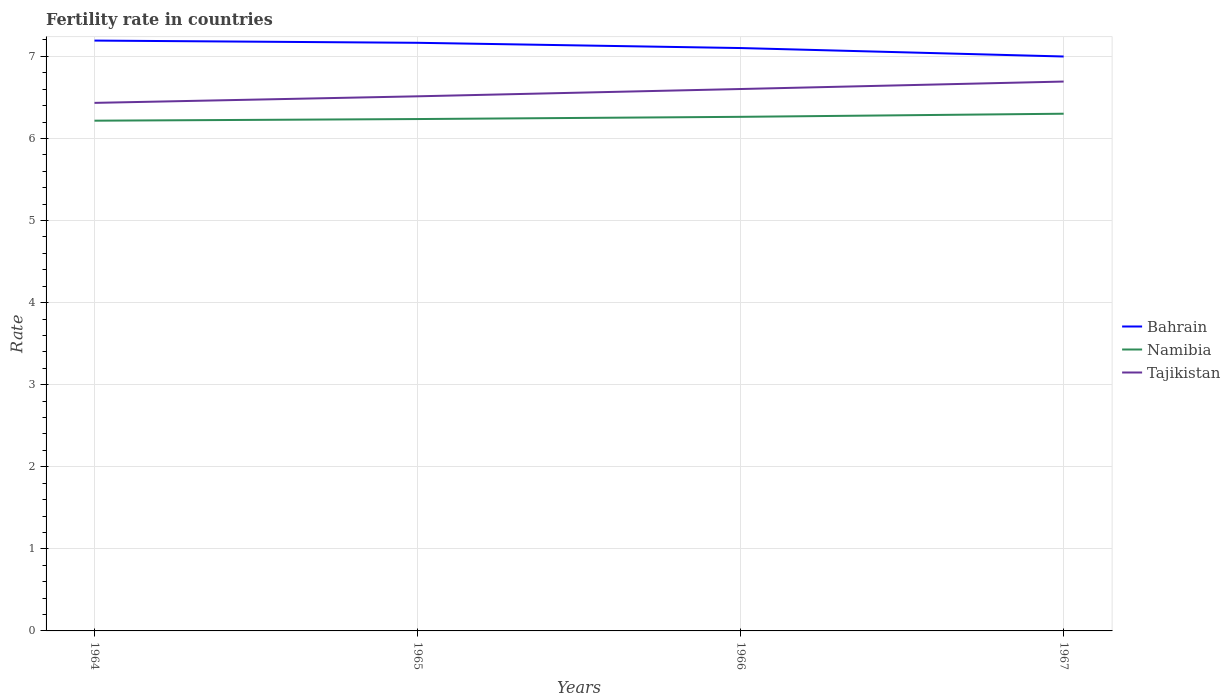Across all years, what is the maximum fertility rate in Bahrain?
Offer a terse response. 7. In which year was the fertility rate in Namibia maximum?
Offer a very short reply. 1964. What is the total fertility rate in Bahrain in the graph?
Make the answer very short. 0.09. What is the difference between the highest and the second highest fertility rate in Bahrain?
Your answer should be compact. 0.19. What is the difference between the highest and the lowest fertility rate in Namibia?
Offer a terse response. 2. How many lines are there?
Provide a short and direct response. 3. Are the values on the major ticks of Y-axis written in scientific E-notation?
Your response must be concise. No. Does the graph contain any zero values?
Make the answer very short. No. How are the legend labels stacked?
Offer a very short reply. Vertical. What is the title of the graph?
Keep it short and to the point. Fertility rate in countries. What is the label or title of the Y-axis?
Offer a terse response. Rate. What is the Rate of Bahrain in 1964?
Offer a terse response. 7.19. What is the Rate of Namibia in 1964?
Ensure brevity in your answer.  6.22. What is the Rate in Tajikistan in 1964?
Provide a succinct answer. 6.43. What is the Rate of Bahrain in 1965?
Your answer should be very brief. 7.17. What is the Rate in Namibia in 1965?
Give a very brief answer. 6.24. What is the Rate of Tajikistan in 1965?
Keep it short and to the point. 6.51. What is the Rate in Bahrain in 1966?
Provide a short and direct response. 7.1. What is the Rate of Namibia in 1966?
Give a very brief answer. 6.26. What is the Rate of Tajikistan in 1966?
Ensure brevity in your answer.  6.6. What is the Rate in Bahrain in 1967?
Provide a short and direct response. 7. What is the Rate in Namibia in 1967?
Ensure brevity in your answer.  6.3. What is the Rate in Tajikistan in 1967?
Ensure brevity in your answer.  6.69. Across all years, what is the maximum Rate in Bahrain?
Make the answer very short. 7.19. Across all years, what is the maximum Rate in Namibia?
Ensure brevity in your answer.  6.3. Across all years, what is the maximum Rate in Tajikistan?
Your answer should be compact. 6.69. Across all years, what is the minimum Rate in Bahrain?
Make the answer very short. 7. Across all years, what is the minimum Rate in Namibia?
Your answer should be very brief. 6.22. Across all years, what is the minimum Rate of Tajikistan?
Ensure brevity in your answer.  6.43. What is the total Rate of Bahrain in the graph?
Keep it short and to the point. 28.46. What is the total Rate of Namibia in the graph?
Keep it short and to the point. 25.02. What is the total Rate in Tajikistan in the graph?
Provide a short and direct response. 26.24. What is the difference between the Rate of Bahrain in 1964 and that in 1965?
Give a very brief answer. 0.03. What is the difference between the Rate in Namibia in 1964 and that in 1965?
Offer a very short reply. -0.02. What is the difference between the Rate in Tajikistan in 1964 and that in 1965?
Make the answer very short. -0.08. What is the difference between the Rate of Bahrain in 1964 and that in 1966?
Provide a succinct answer. 0.09. What is the difference between the Rate in Namibia in 1964 and that in 1966?
Make the answer very short. -0.05. What is the difference between the Rate of Tajikistan in 1964 and that in 1966?
Provide a succinct answer. -0.17. What is the difference between the Rate in Bahrain in 1964 and that in 1967?
Offer a terse response. 0.19. What is the difference between the Rate in Namibia in 1964 and that in 1967?
Your answer should be compact. -0.09. What is the difference between the Rate of Tajikistan in 1964 and that in 1967?
Your response must be concise. -0.26. What is the difference between the Rate in Bahrain in 1965 and that in 1966?
Offer a very short reply. 0.06. What is the difference between the Rate of Namibia in 1965 and that in 1966?
Provide a short and direct response. -0.03. What is the difference between the Rate in Tajikistan in 1965 and that in 1966?
Ensure brevity in your answer.  -0.09. What is the difference between the Rate in Bahrain in 1965 and that in 1967?
Give a very brief answer. 0.17. What is the difference between the Rate of Namibia in 1965 and that in 1967?
Provide a succinct answer. -0.07. What is the difference between the Rate of Tajikistan in 1965 and that in 1967?
Your answer should be very brief. -0.18. What is the difference between the Rate in Bahrain in 1966 and that in 1967?
Keep it short and to the point. 0.1. What is the difference between the Rate of Namibia in 1966 and that in 1967?
Offer a very short reply. -0.04. What is the difference between the Rate of Tajikistan in 1966 and that in 1967?
Make the answer very short. -0.09. What is the difference between the Rate in Bahrain in 1964 and the Rate in Namibia in 1965?
Offer a terse response. 0.96. What is the difference between the Rate of Bahrain in 1964 and the Rate of Tajikistan in 1965?
Your response must be concise. 0.68. What is the difference between the Rate of Namibia in 1964 and the Rate of Tajikistan in 1965?
Make the answer very short. -0.3. What is the difference between the Rate in Bahrain in 1964 and the Rate in Namibia in 1966?
Give a very brief answer. 0.93. What is the difference between the Rate in Bahrain in 1964 and the Rate in Tajikistan in 1966?
Offer a terse response. 0.59. What is the difference between the Rate in Namibia in 1964 and the Rate in Tajikistan in 1966?
Your response must be concise. -0.39. What is the difference between the Rate in Bahrain in 1964 and the Rate in Namibia in 1967?
Give a very brief answer. 0.89. What is the difference between the Rate in Bahrain in 1964 and the Rate in Tajikistan in 1967?
Provide a succinct answer. 0.5. What is the difference between the Rate in Namibia in 1964 and the Rate in Tajikistan in 1967?
Offer a very short reply. -0.48. What is the difference between the Rate of Bahrain in 1965 and the Rate of Namibia in 1966?
Your response must be concise. 0.9. What is the difference between the Rate of Bahrain in 1965 and the Rate of Tajikistan in 1966?
Give a very brief answer. 0.56. What is the difference between the Rate of Namibia in 1965 and the Rate of Tajikistan in 1966?
Give a very brief answer. -0.37. What is the difference between the Rate in Bahrain in 1965 and the Rate in Namibia in 1967?
Provide a short and direct response. 0.86. What is the difference between the Rate of Bahrain in 1965 and the Rate of Tajikistan in 1967?
Provide a succinct answer. 0.47. What is the difference between the Rate of Namibia in 1965 and the Rate of Tajikistan in 1967?
Provide a short and direct response. -0.46. What is the difference between the Rate in Bahrain in 1966 and the Rate in Namibia in 1967?
Ensure brevity in your answer.  0.8. What is the difference between the Rate of Bahrain in 1966 and the Rate of Tajikistan in 1967?
Ensure brevity in your answer.  0.41. What is the difference between the Rate of Namibia in 1966 and the Rate of Tajikistan in 1967?
Provide a succinct answer. -0.43. What is the average Rate of Bahrain per year?
Keep it short and to the point. 7.11. What is the average Rate of Namibia per year?
Offer a terse response. 6.25. What is the average Rate in Tajikistan per year?
Keep it short and to the point. 6.56. In the year 1964, what is the difference between the Rate of Bahrain and Rate of Namibia?
Offer a terse response. 0.98. In the year 1964, what is the difference between the Rate in Bahrain and Rate in Tajikistan?
Provide a short and direct response. 0.76. In the year 1964, what is the difference between the Rate of Namibia and Rate of Tajikistan?
Provide a succinct answer. -0.22. In the year 1965, what is the difference between the Rate in Bahrain and Rate in Namibia?
Provide a succinct answer. 0.93. In the year 1965, what is the difference between the Rate in Bahrain and Rate in Tajikistan?
Your answer should be very brief. 0.65. In the year 1965, what is the difference between the Rate in Namibia and Rate in Tajikistan?
Ensure brevity in your answer.  -0.28. In the year 1966, what is the difference between the Rate of Bahrain and Rate of Namibia?
Offer a terse response. 0.84. In the year 1966, what is the difference between the Rate of Bahrain and Rate of Tajikistan?
Your answer should be very brief. 0.5. In the year 1966, what is the difference between the Rate of Namibia and Rate of Tajikistan?
Give a very brief answer. -0.34. In the year 1967, what is the difference between the Rate of Bahrain and Rate of Namibia?
Ensure brevity in your answer.  0.7. In the year 1967, what is the difference between the Rate of Bahrain and Rate of Tajikistan?
Your answer should be very brief. 0.3. In the year 1967, what is the difference between the Rate of Namibia and Rate of Tajikistan?
Ensure brevity in your answer.  -0.39. What is the ratio of the Rate of Namibia in 1964 to that in 1965?
Give a very brief answer. 1. What is the ratio of the Rate in Tajikistan in 1964 to that in 1965?
Make the answer very short. 0.99. What is the ratio of the Rate of Bahrain in 1964 to that in 1966?
Provide a succinct answer. 1.01. What is the ratio of the Rate of Tajikistan in 1964 to that in 1966?
Offer a very short reply. 0.97. What is the ratio of the Rate of Bahrain in 1964 to that in 1967?
Offer a terse response. 1.03. What is the ratio of the Rate in Namibia in 1964 to that in 1967?
Provide a succinct answer. 0.99. What is the ratio of the Rate of Tajikistan in 1964 to that in 1967?
Your answer should be very brief. 0.96. What is the ratio of the Rate in Namibia in 1965 to that in 1966?
Offer a very short reply. 1. What is the ratio of the Rate of Tajikistan in 1965 to that in 1966?
Offer a very short reply. 0.99. What is the ratio of the Rate in Bahrain in 1965 to that in 1967?
Offer a terse response. 1.02. What is the ratio of the Rate of Tajikistan in 1965 to that in 1967?
Provide a short and direct response. 0.97. What is the ratio of the Rate of Bahrain in 1966 to that in 1967?
Make the answer very short. 1.01. What is the ratio of the Rate of Namibia in 1966 to that in 1967?
Ensure brevity in your answer.  0.99. What is the ratio of the Rate of Tajikistan in 1966 to that in 1967?
Provide a succinct answer. 0.99. What is the difference between the highest and the second highest Rate of Bahrain?
Offer a very short reply. 0.03. What is the difference between the highest and the second highest Rate of Namibia?
Provide a short and direct response. 0.04. What is the difference between the highest and the second highest Rate of Tajikistan?
Keep it short and to the point. 0.09. What is the difference between the highest and the lowest Rate of Bahrain?
Provide a short and direct response. 0.19. What is the difference between the highest and the lowest Rate in Namibia?
Ensure brevity in your answer.  0.09. What is the difference between the highest and the lowest Rate of Tajikistan?
Provide a short and direct response. 0.26. 